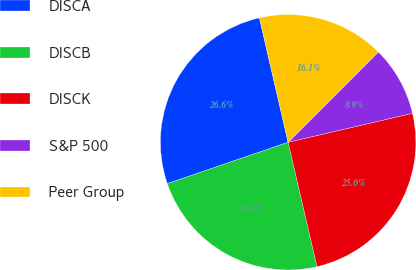Convert chart to OTSL. <chart><loc_0><loc_0><loc_500><loc_500><pie_chart><fcel>DISCA<fcel>DISCB<fcel>DISCK<fcel>S&P 500<fcel>Peer Group<nl><fcel>26.64%<fcel>23.38%<fcel>25.01%<fcel>8.86%<fcel>16.1%<nl></chart> 